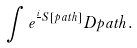<formula> <loc_0><loc_0><loc_500><loc_500>\int e ^ { \frac { i } { } S [ p a t h ] } D p a t h .</formula> 